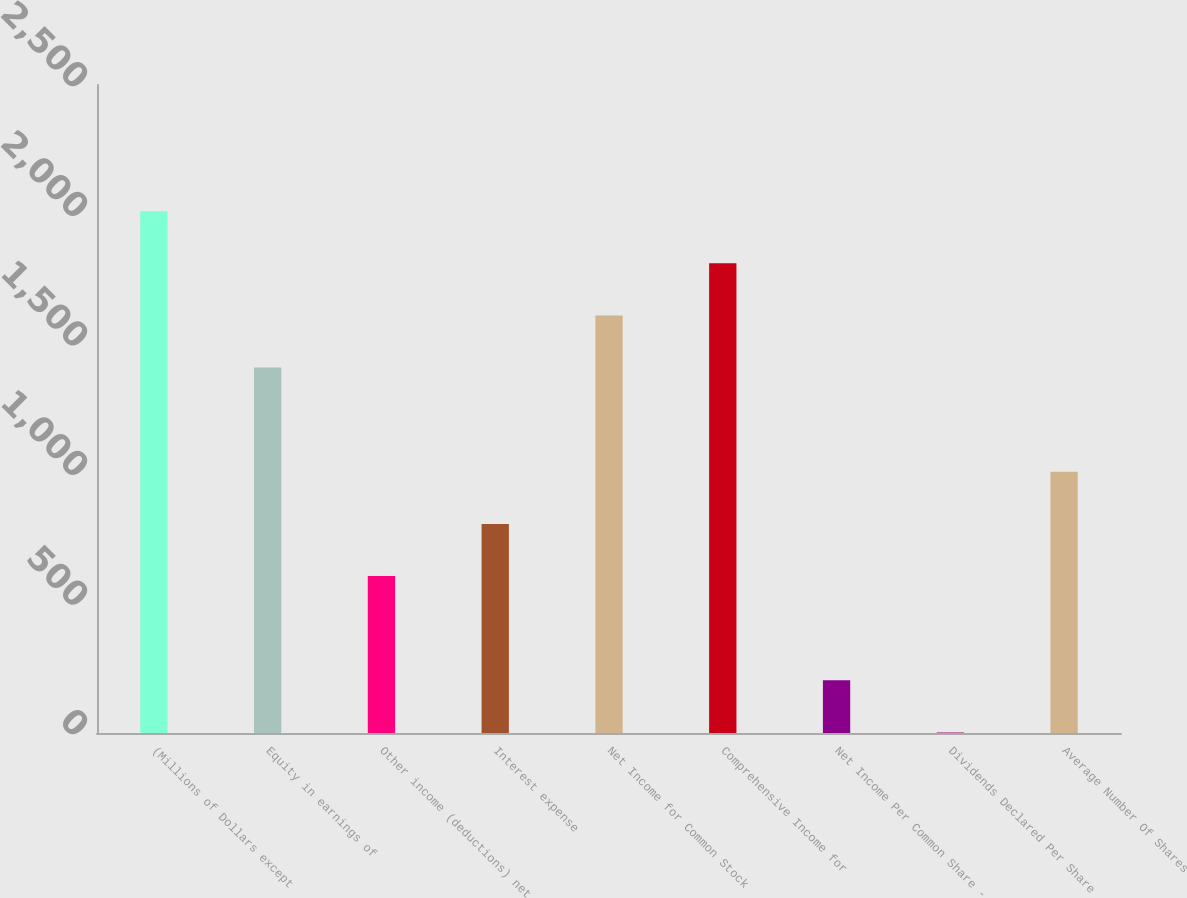Convert chart. <chart><loc_0><loc_0><loc_500><loc_500><bar_chart><fcel>(Millions of Dollars except<fcel>Equity in earnings of<fcel>Other income (deductions) net<fcel>Interest expense<fcel>Net Income for Common Stock<fcel>Comprehensive Income for<fcel>Net Income Per Common Share -<fcel>Dividends Declared Per Share<fcel>Average Number Of Shares<nl><fcel>2013<fcel>1409.81<fcel>605.61<fcel>806.66<fcel>1610.86<fcel>1811.91<fcel>203.51<fcel>2.46<fcel>1007.71<nl></chart> 